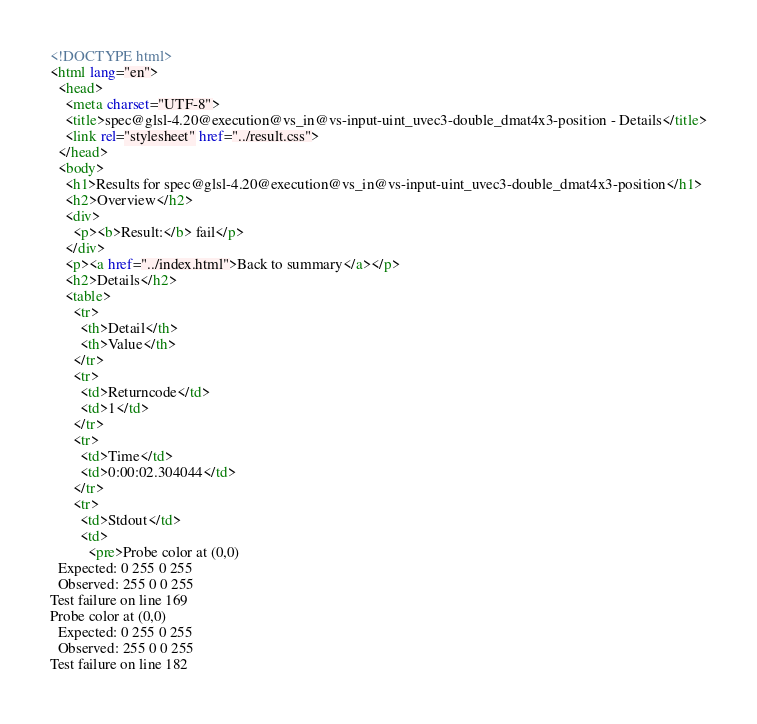Convert code to text. <code><loc_0><loc_0><loc_500><loc_500><_HTML_><!DOCTYPE html>
<html lang="en">
  <head>
    <meta charset="UTF-8">
    <title>spec@glsl-4.20@execution@vs_in@vs-input-uint_uvec3-double_dmat4x3-position - Details</title>
    <link rel="stylesheet" href="../result.css">
  </head>
  <body>
    <h1>Results for spec@glsl-4.20@execution@vs_in@vs-input-uint_uvec3-double_dmat4x3-position</h1>
    <h2>Overview</h2>
    <div>
      <p><b>Result:</b> fail</p>
    </div>
    <p><a href="../index.html">Back to summary</a></p>
    <h2>Details</h2>
    <table>
      <tr>
        <th>Detail</th>
        <th>Value</th>
      </tr>
      <tr>
        <td>Returncode</td>
        <td>1</td>
      </tr>
      <tr>
        <td>Time</td>
        <td>0:00:02.304044</td>
      </tr>
      <tr>
        <td>Stdout</td>
        <td>
          <pre>Probe color at (0,0)
  Expected: 0 255 0 255
  Observed: 255 0 0 255
Test failure on line 169
Probe color at (0,0)
  Expected: 0 255 0 255
  Observed: 255 0 0 255
Test failure on line 182</code> 